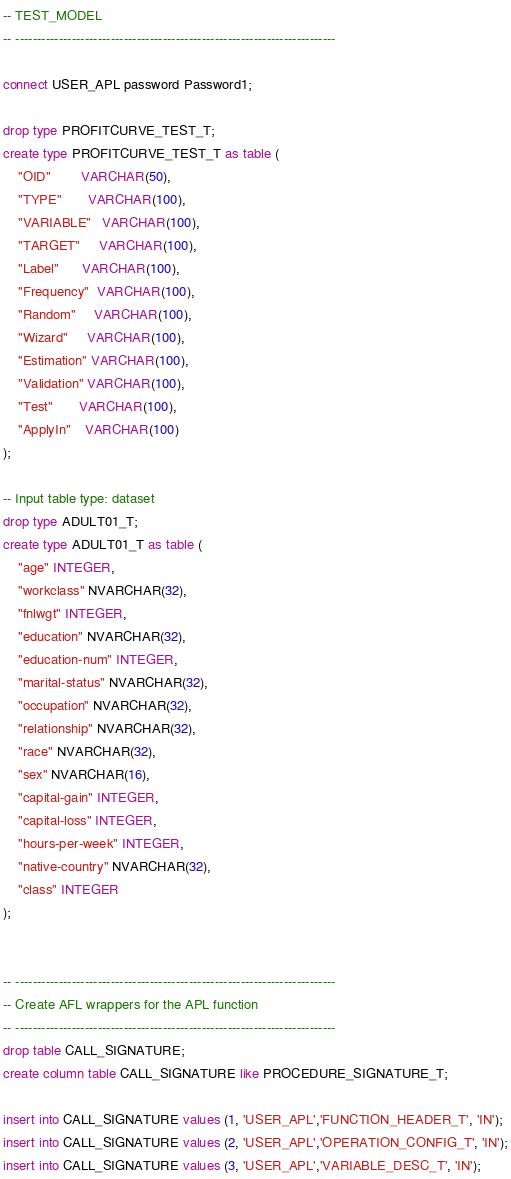Convert code to text. <code><loc_0><loc_0><loc_500><loc_500><_SQL_>-- TEST_MODEL 
-- --------------------------------------------------------------------------

connect USER_APL password Password1;

drop type PROFITCURVE_TEST_T;
create type PROFITCURVE_TEST_T as table (
    "OID"        VARCHAR(50),
    "TYPE"       VARCHAR(100),
    "VARIABLE"   VARCHAR(100),
    "TARGET"     VARCHAR(100),
    "Label"      VARCHAR(100),
    "Frequency"  VARCHAR(100),
    "Random"     VARCHAR(100),
    "Wizard"     VARCHAR(100),
    "Estimation" VARCHAR(100),
    "Validation" VARCHAR(100),
    "Test"       VARCHAR(100),
    "ApplyIn"    VARCHAR(100)
);

-- Input table type: dataset
drop type ADULT01_T;
create type ADULT01_T as table (
	"age" INTEGER,
	"workclass" NVARCHAR(32),
	"fnlwgt" INTEGER,
	"education" NVARCHAR(32),
	"education-num" INTEGER,
	"marital-status" NVARCHAR(32),
	"occupation" NVARCHAR(32),
	"relationship" NVARCHAR(32),
	"race" NVARCHAR(32),
	"sex" NVARCHAR(16),
	"capital-gain" INTEGER,
	"capital-loss" INTEGER,
	"hours-per-week" INTEGER,
	"native-country" NVARCHAR(32),
	"class" INTEGER
);


-- --------------------------------------------------------------------------
-- Create AFL wrappers for the APL function
-- --------------------------------------------------------------------------
drop table CALL_SIGNATURE;
create column table CALL_SIGNATURE like PROCEDURE_SIGNATURE_T;

insert into CALL_SIGNATURE values (1, 'USER_APL','FUNCTION_HEADER_T', 'IN');
insert into CALL_SIGNATURE values (2, 'USER_APL','OPERATION_CONFIG_T', 'IN');
insert into CALL_SIGNATURE values (3, 'USER_APL','VARIABLE_DESC_T', 'IN');</code> 